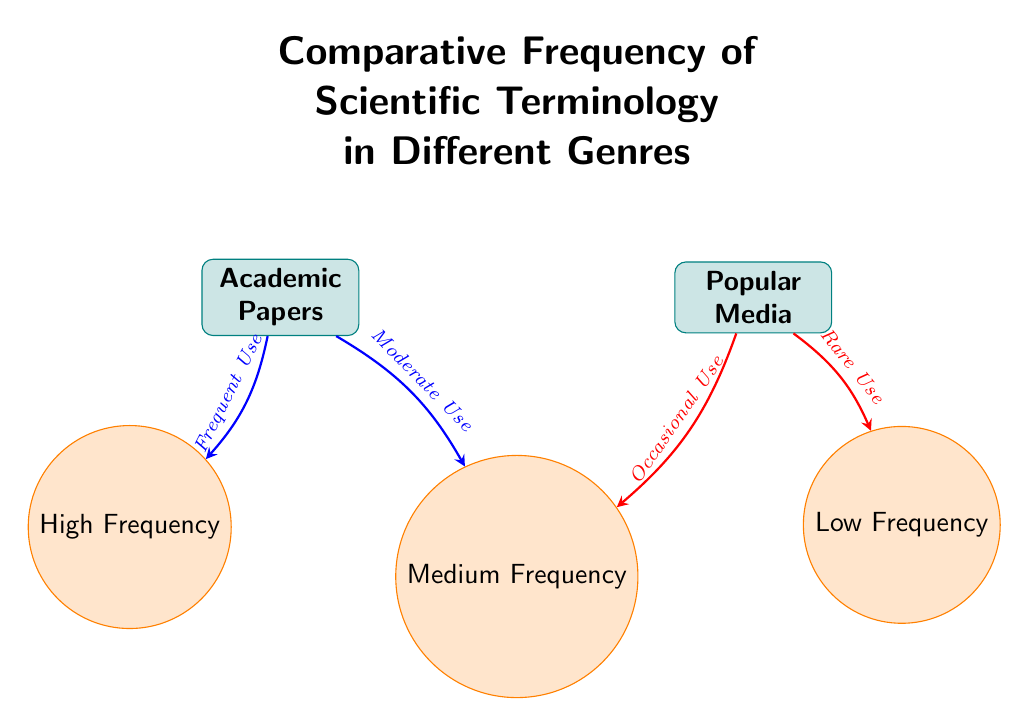What are the two genres compared in the diagram? The diagram explicitly labels the two genres as "Academic Papers" and "Popular Media" at the top.
Answer: Academic Papers and Popular Media Which frequency category is associated with academic papers? The arrows leading from the "Academic Papers" node point towards the "High Frequency" and "Medium Frequency" nodes. This indicates that academic papers are associated with these two categories of frequency.
Answer: High Frequency, Medium Frequency What type of use is associated with popular media in the medium frequency category? The arrow from the "Popular Media" node to the "Medium Frequency" node indicates that there is an "Occasional Use" of scientific terminology in this frequency category for popular media.
Answer: Occasional Use How many frequency categories are shown in the diagram? The diagram features three frequency categories: High Frequency, Medium Frequency, and Low Frequency, which are distinctly arranged below the genre nodes.
Answer: Three Which genre has the highest frequency of scientific terminology? The "Academic Papers" genre is connected to the "High Frequency" category by a blue arrow labeled "Frequent Use," indicating it has the highest frequency of scientific terminology.
Answer: Academic Papers What can be inferred about the frequency of scientific terminology in popular media compared to academic papers? The arrows and labels imply that popular media has a lower frequency of scientific terminology compared to academic papers, which are linked to both high and medium frequency, while popular media is linked primarily to medium and low frequencies.
Answer: Lower Frequency How does the diagram represent the relationship between the popularity of media and the frequency of scientific terminology? The arrows indicate a directional relationship, with the "Popular Media" node leading to "Medium Frequency" and "Low Frequency," showing that as the genre becomes more popular, the frequency of scientific terminology used decreases.
Answer: Decreases What is the visual style of the genre nodes in the diagram? The genre nodes are represented as rectangles with rounded corners, drawn in teal with a fill of teal color, and have a bold sans-serif font.
Answer: Rectangles with rounded corners, teal color 